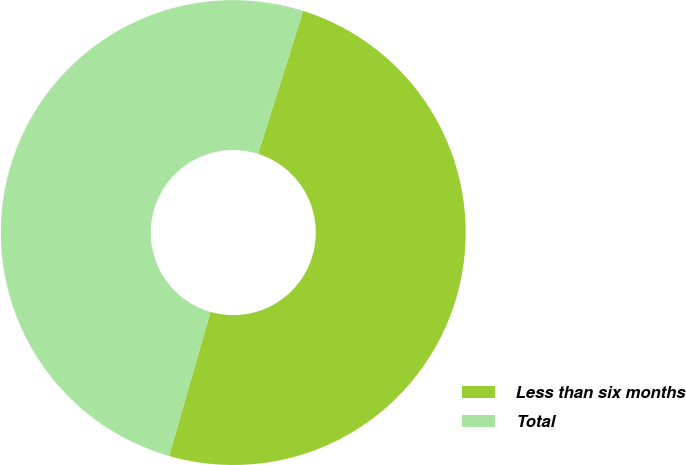<chart> <loc_0><loc_0><loc_500><loc_500><pie_chart><fcel>Less than six months<fcel>Total<nl><fcel>49.59%<fcel>50.41%<nl></chart> 